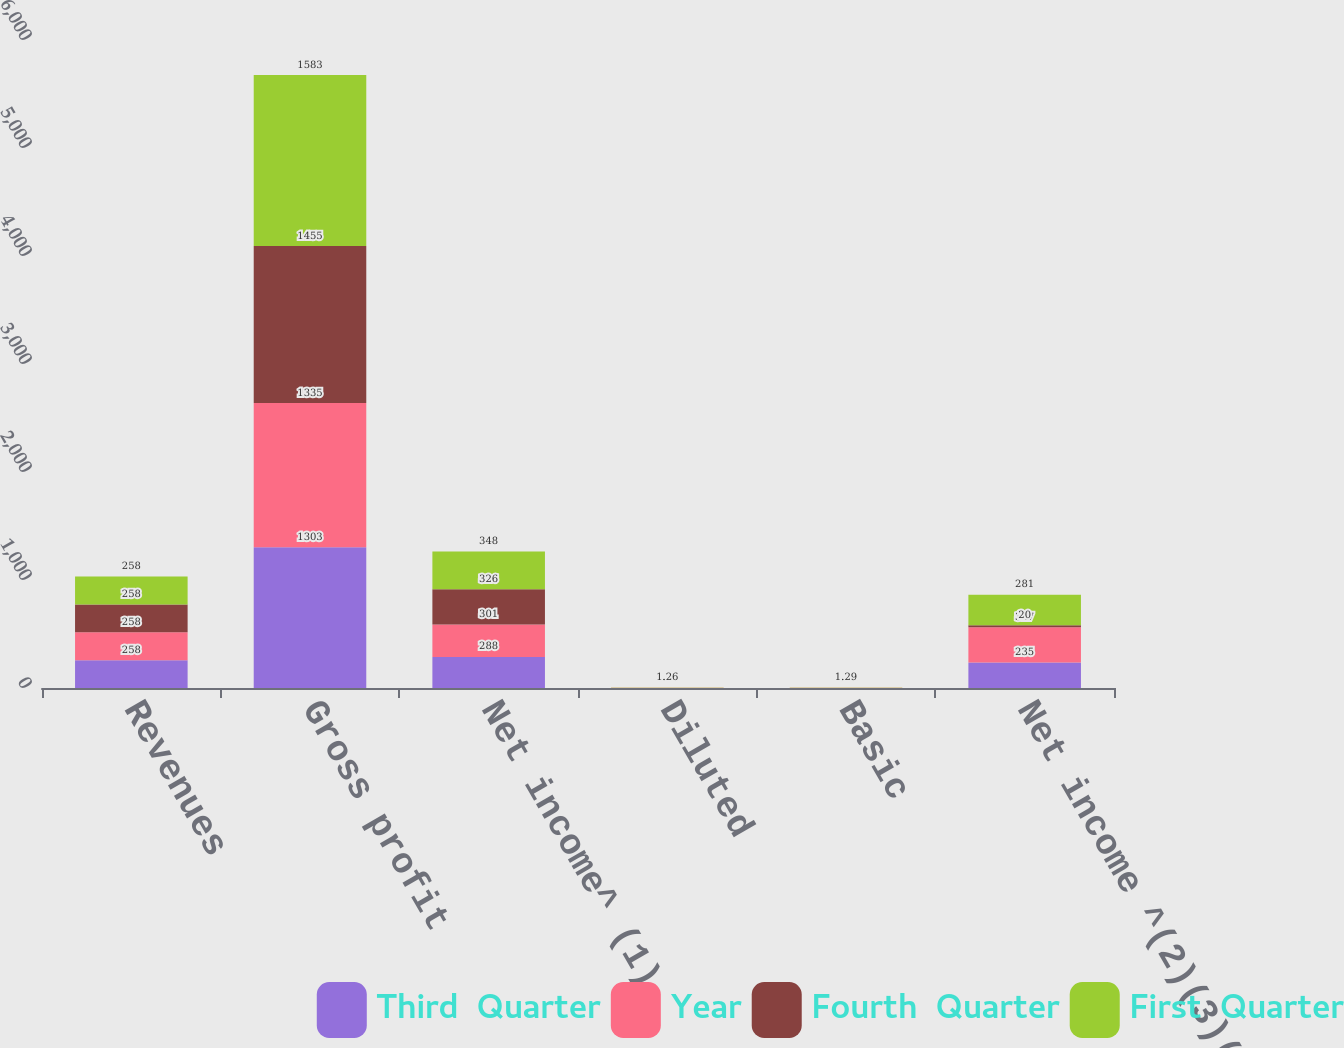Convert chart. <chart><loc_0><loc_0><loc_500><loc_500><stacked_bar_chart><ecel><fcel>Revenues<fcel>Gross profit<fcel>Net income^ (1)<fcel>Diluted<fcel>Basic<fcel>Net income ^(2)(3)(4)(5)<nl><fcel>Third  Quarter<fcel>258<fcel>1303<fcel>288<fcel>1.06<fcel>1.07<fcel>235<nl><fcel>Year<fcel>258<fcel>1335<fcel>301<fcel>1.11<fcel>1.13<fcel>327<nl><fcel>Fourth  Quarter<fcel>258<fcel>1455<fcel>326<fcel>1.19<fcel>1.21<fcel>20<nl><fcel>First  Quarter<fcel>258<fcel>1583<fcel>348<fcel>1.26<fcel>1.29<fcel>281<nl></chart> 